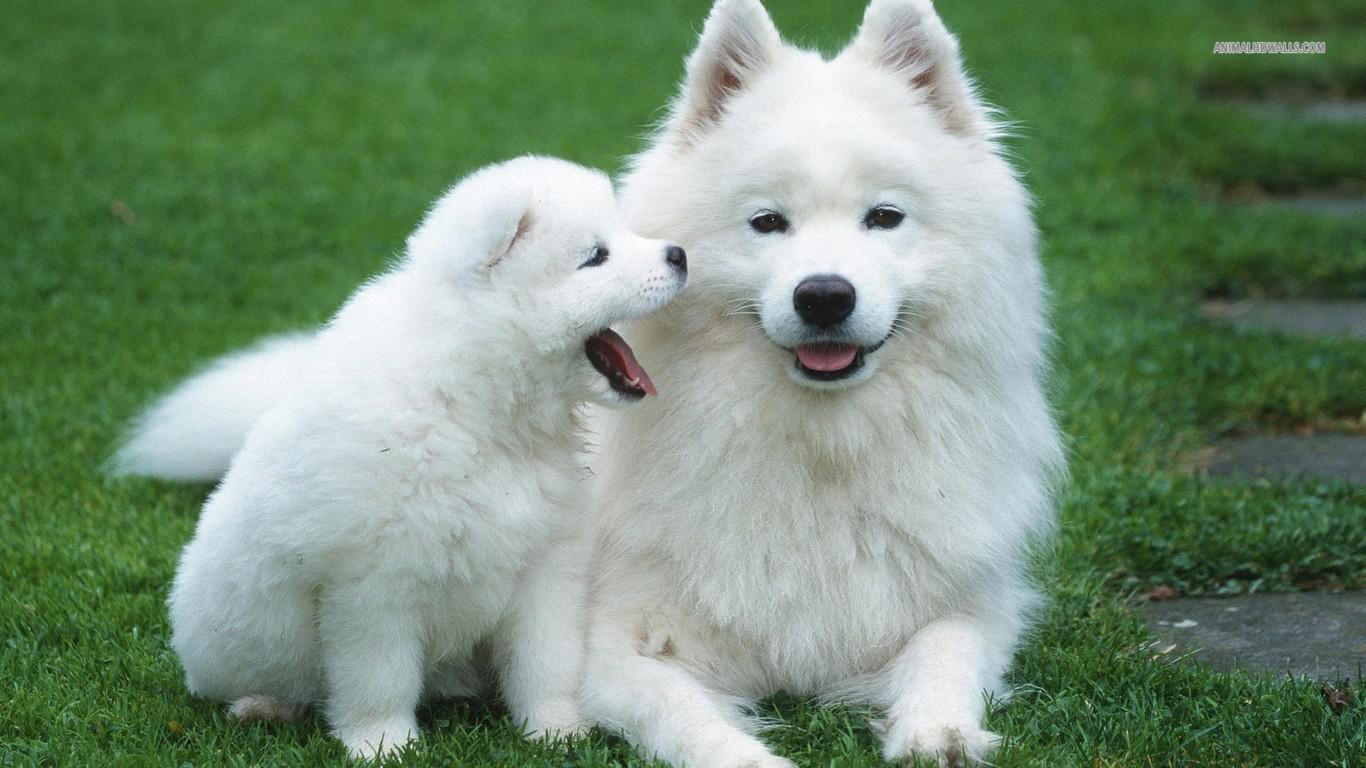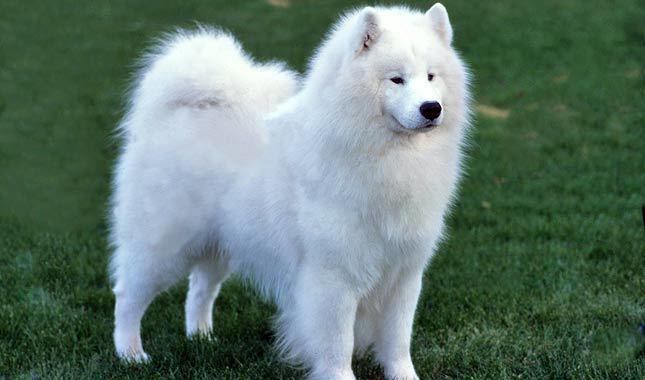The first image is the image on the left, the second image is the image on the right. For the images displayed, is the sentence "There is an adult dog and a puppy in the left image." factually correct? Answer yes or no. Yes. 